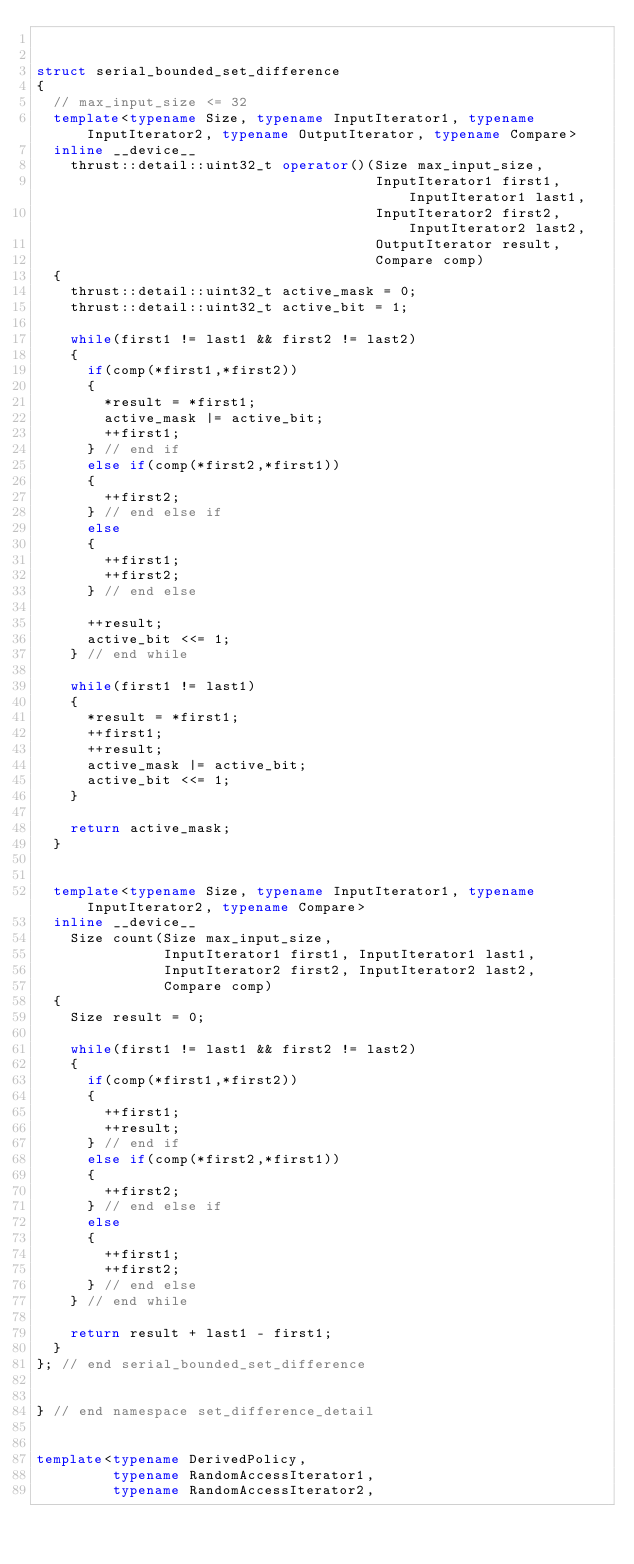<code> <loc_0><loc_0><loc_500><loc_500><_C++_>

struct serial_bounded_set_difference
{
  // max_input_size <= 32
  template<typename Size, typename InputIterator1, typename InputIterator2, typename OutputIterator, typename Compare>
  inline __device__
    thrust::detail::uint32_t operator()(Size max_input_size,
                                        InputIterator1 first1, InputIterator1 last1,
                                        InputIterator2 first2, InputIterator2 last2,
                                        OutputIterator result,
                                        Compare comp)
  {
    thrust::detail::uint32_t active_mask = 0;
    thrust::detail::uint32_t active_bit = 1;
  
    while(first1 != last1 && first2 != last2)
    {
      if(comp(*first1,*first2))
      {
        *result = *first1;
        active_mask |= active_bit;
        ++first1;
      } // end if
      else if(comp(*first2,*first1))
      {
        ++first2;
      } // end else if
      else
      {
        ++first1;
        ++first2;
      } // end else
  
      ++result;
      active_bit <<= 1;
    } // end while

    while(first1 != last1)
    {
      *result = *first1;
      ++first1;
      ++result;
      active_mask |= active_bit;
      active_bit <<= 1;
    }
  
    return active_mask;
  }


  template<typename Size, typename InputIterator1, typename InputIterator2, typename Compare>
  inline __device__
    Size count(Size max_input_size,
               InputIterator1 first1, InputIterator1 last1,
               InputIterator2 first2, InputIterator2 last2,
               Compare comp)
  {
    Size result = 0;
  
    while(first1 != last1 && first2 != last2)
    {
      if(comp(*first1,*first2))
      {
        ++first1;
        ++result;
      } // end if
      else if(comp(*first2,*first1))
      {
        ++first2;
      } // end else if
      else
      {
        ++first1;
        ++first2;
      } // end else
    } // end while
  
    return result + last1 - first1;
  }
}; // end serial_bounded_set_difference


} // end namespace set_difference_detail


template<typename DerivedPolicy,
         typename RandomAccessIterator1,
         typename RandomAccessIterator2, </code> 